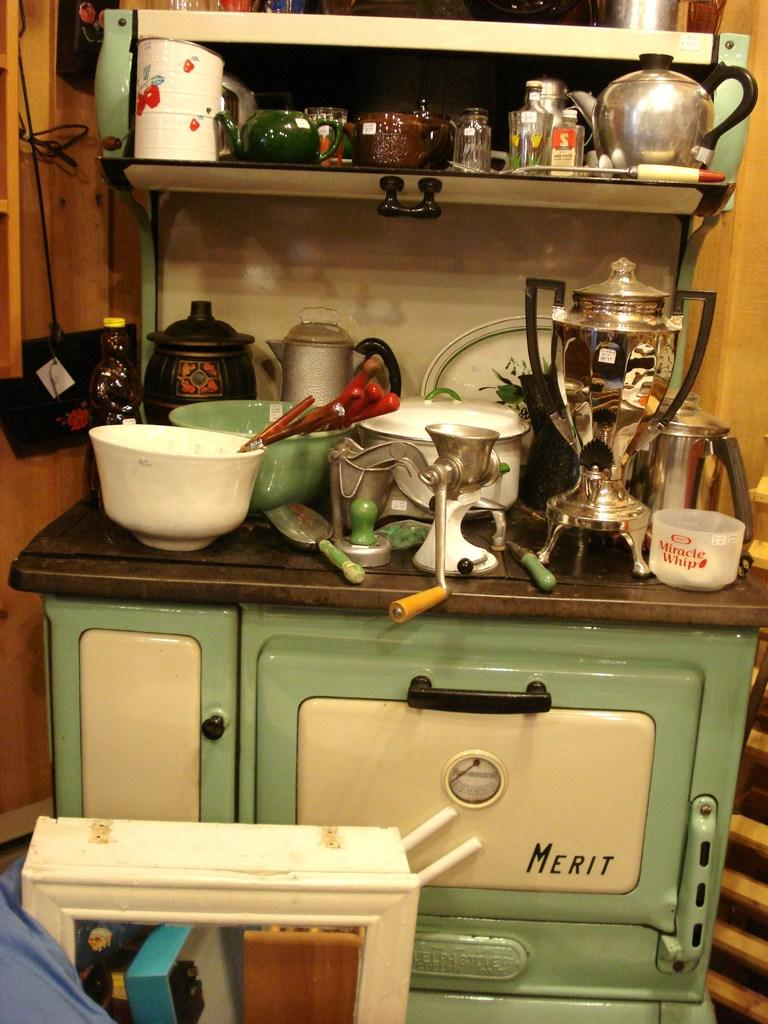<image>
Create a compact narrative representing the image presented. A green stove with the name Merit on it. 